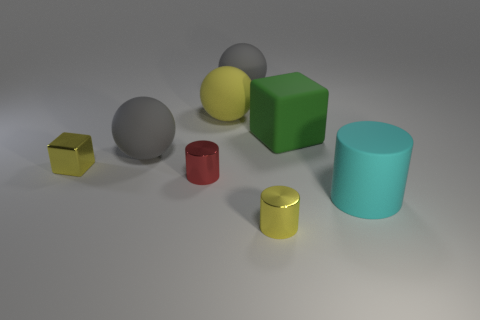Are there any other things of the same color as the metallic block?
Offer a very short reply. Yes. How many objects are either rubber objects or shiny things to the right of the tiny yellow block?
Keep it short and to the point. 7. What material is the thing in front of the matte thing that is in front of the tiny yellow metal object behind the rubber cylinder?
Ensure brevity in your answer.  Metal. What is the size of the cube that is the same material as the small red thing?
Ensure brevity in your answer.  Small. What is the color of the cube that is to the left of the metallic object that is right of the big yellow object?
Provide a succinct answer. Yellow. How many red cylinders are made of the same material as the yellow cylinder?
Your response must be concise. 1. How many metallic objects are yellow cylinders or red objects?
Your response must be concise. 2. There is another cylinder that is the same size as the red metal cylinder; what is its material?
Make the answer very short. Metal. Is there a yellow cube made of the same material as the cyan cylinder?
Ensure brevity in your answer.  No. What is the shape of the tiny object left of the matte sphere to the left of the small metallic cylinder that is to the left of the tiny yellow cylinder?
Your response must be concise. Cube. 